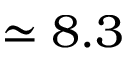<formula> <loc_0><loc_0><loc_500><loc_500>\simeq 8 . 3</formula> 